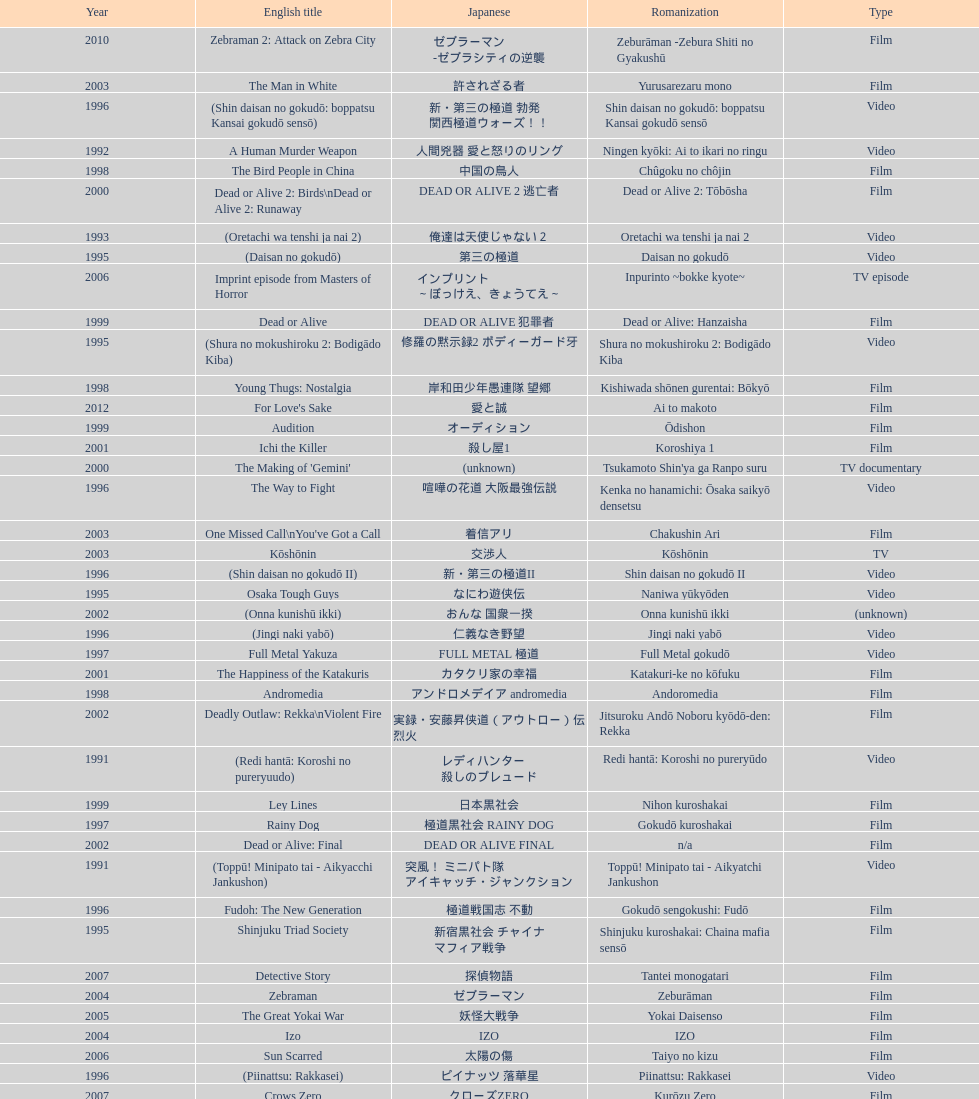Which title is listed next after "the way to fight"? Fudoh: The New Generation. 